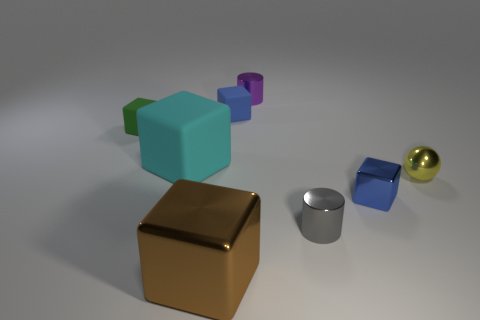There is a small thing that is left of the large shiny cube; what is its material?
Provide a succinct answer. Rubber. Are there the same number of tiny blue blocks in front of the yellow metal object and tiny metal objects?
Your answer should be compact. No. Does the yellow metal thing have the same size as the green rubber cube?
Your answer should be compact. Yes. There is a small rubber thing right of the large thing that is on the left side of the brown metallic cube; is there a small green rubber object that is on the right side of it?
Offer a very short reply. No. There is a green object that is the same shape as the brown metal thing; what material is it?
Offer a terse response. Rubber. How many metal things are to the right of the rubber thing to the right of the large brown thing?
Offer a very short reply. 4. There is a metallic block that is left of the small blue thing to the left of the tiny metal thing that is to the left of the small gray cylinder; what is its size?
Give a very brief answer. Large. What color is the metallic cube that is in front of the small cube to the right of the blue rubber object?
Make the answer very short. Brown. What number of other things are made of the same material as the big cyan cube?
Offer a terse response. 2. What number of other objects are the same color as the big rubber thing?
Your answer should be compact. 0. 